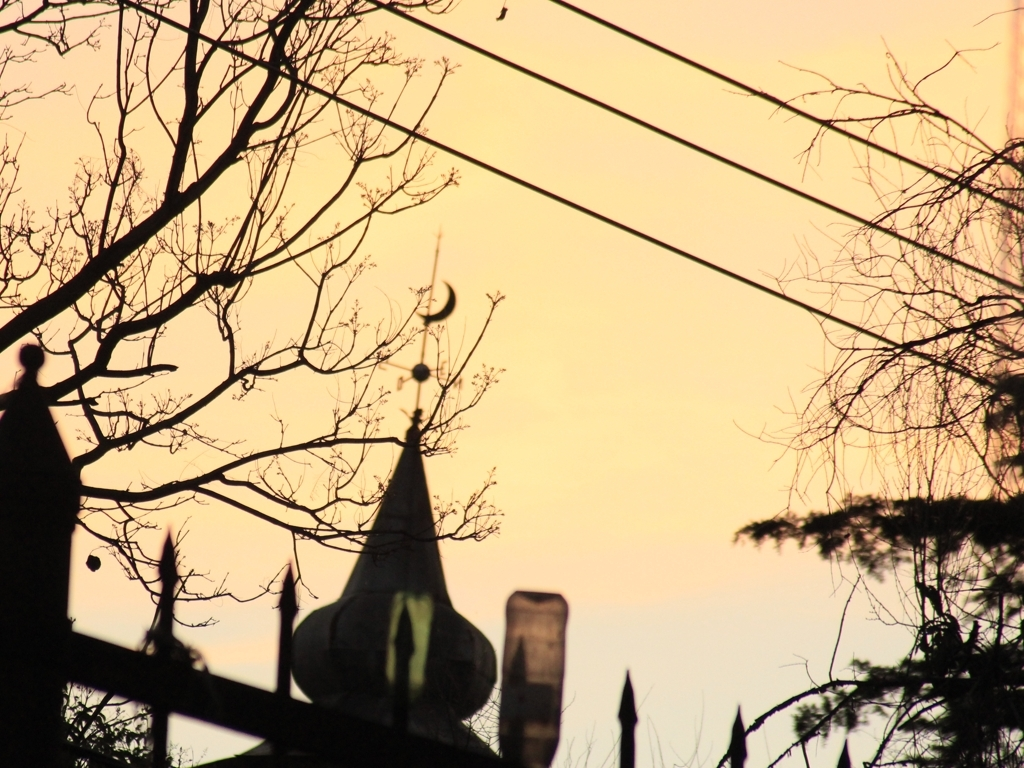Is the overall clarity of the image good? The image appears to have a moderate level of clarity; however, the foreground is silhouetted due to backlighting from the sunset, leading to more emphasis on shapes rather than fine details. The silhouette of the structures and trees creates a distinct contrast against the softly lit sky, which may be perceived as artistic rather than lacking clarity. 